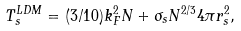<formula> <loc_0><loc_0><loc_500><loc_500>T ^ { L D M } _ { s } = ( 3 / 1 0 ) k ^ { 2 } _ { F } N + \sigma _ { s } N ^ { 2 / 3 } 4 \pi r ^ { 2 } _ { s } ,</formula> 